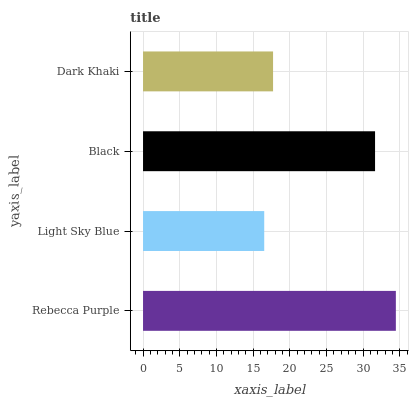Is Light Sky Blue the minimum?
Answer yes or no. Yes. Is Rebecca Purple the maximum?
Answer yes or no. Yes. Is Black the minimum?
Answer yes or no. No. Is Black the maximum?
Answer yes or no. No. Is Black greater than Light Sky Blue?
Answer yes or no. Yes. Is Light Sky Blue less than Black?
Answer yes or no. Yes. Is Light Sky Blue greater than Black?
Answer yes or no. No. Is Black less than Light Sky Blue?
Answer yes or no. No. Is Black the high median?
Answer yes or no. Yes. Is Dark Khaki the low median?
Answer yes or no. Yes. Is Light Sky Blue the high median?
Answer yes or no. No. Is Black the low median?
Answer yes or no. No. 